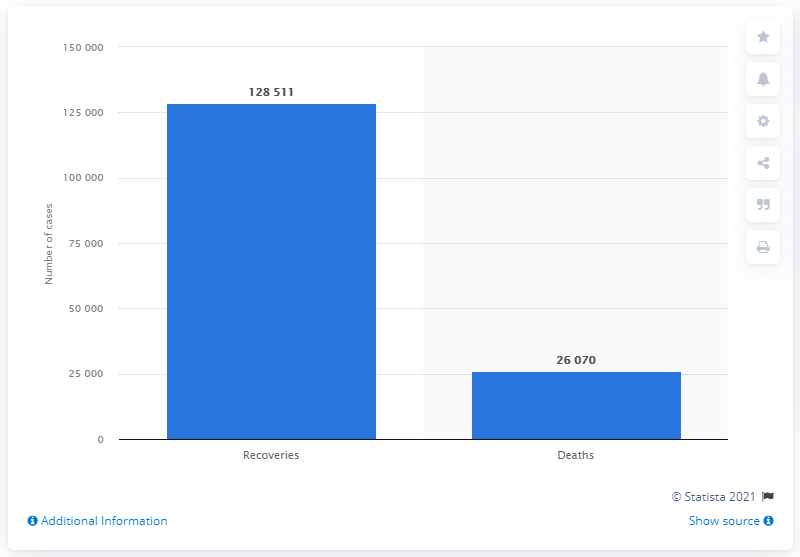Point out several critical features in this image. As of May 7, 2020, a total of 128,511 patients were able to regain their health. 